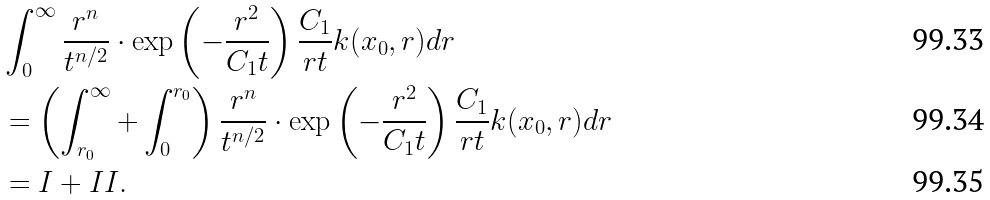<formula> <loc_0><loc_0><loc_500><loc_500>& \int ^ { \infty } _ { 0 } \frac { r ^ { n } } { t ^ { n / 2 } } \cdot \exp \left ( - \frac { r ^ { 2 } } { C _ { 1 } t } \right ) \frac { C _ { 1 } } { r t } k ( x _ { 0 } , r ) d r \\ & = \left ( \int ^ { \infty } _ { r _ { 0 } } + \int ^ { r _ { 0 } } _ { 0 } \right ) \frac { r ^ { n } } { t ^ { n / 2 } } \cdot \exp \left ( - \frac { r ^ { 2 } } { C _ { 1 } t } \right ) \frac { C _ { 1 } } { r t } k ( x _ { 0 } , r ) d r \\ & = I + I I .</formula> 